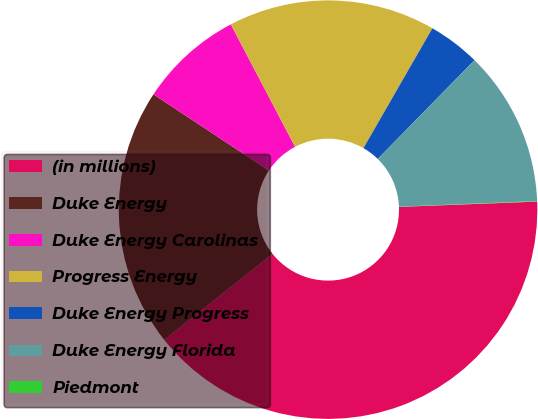Convert chart. <chart><loc_0><loc_0><loc_500><loc_500><pie_chart><fcel>(in millions)<fcel>Duke Energy<fcel>Duke Energy Carolinas<fcel>Progress Energy<fcel>Duke Energy Progress<fcel>Duke Energy Florida<fcel>Piedmont<nl><fcel>39.93%<fcel>19.98%<fcel>8.02%<fcel>16.0%<fcel>4.03%<fcel>12.01%<fcel>0.04%<nl></chart> 